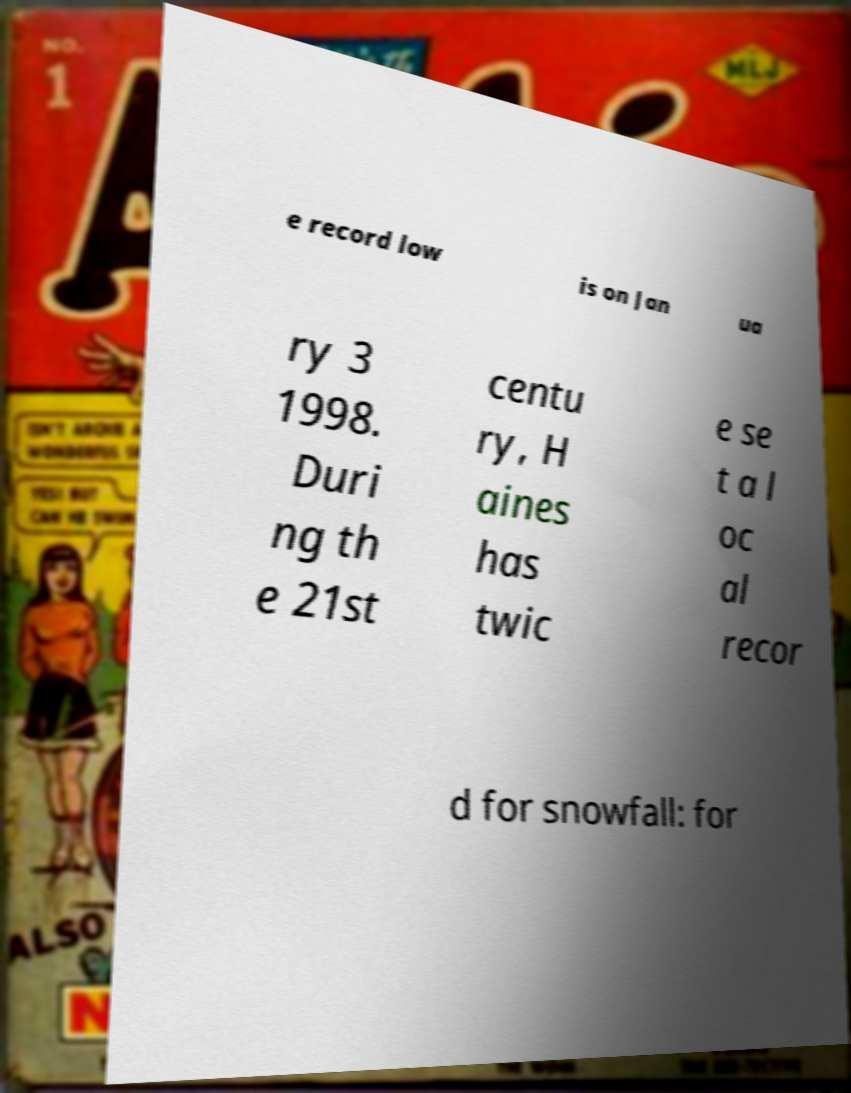What messages or text are displayed in this image? I need them in a readable, typed format. e record low is on Jan ua ry 3 1998. Duri ng th e 21st centu ry, H aines has twic e se t a l oc al recor d for snowfall: for 